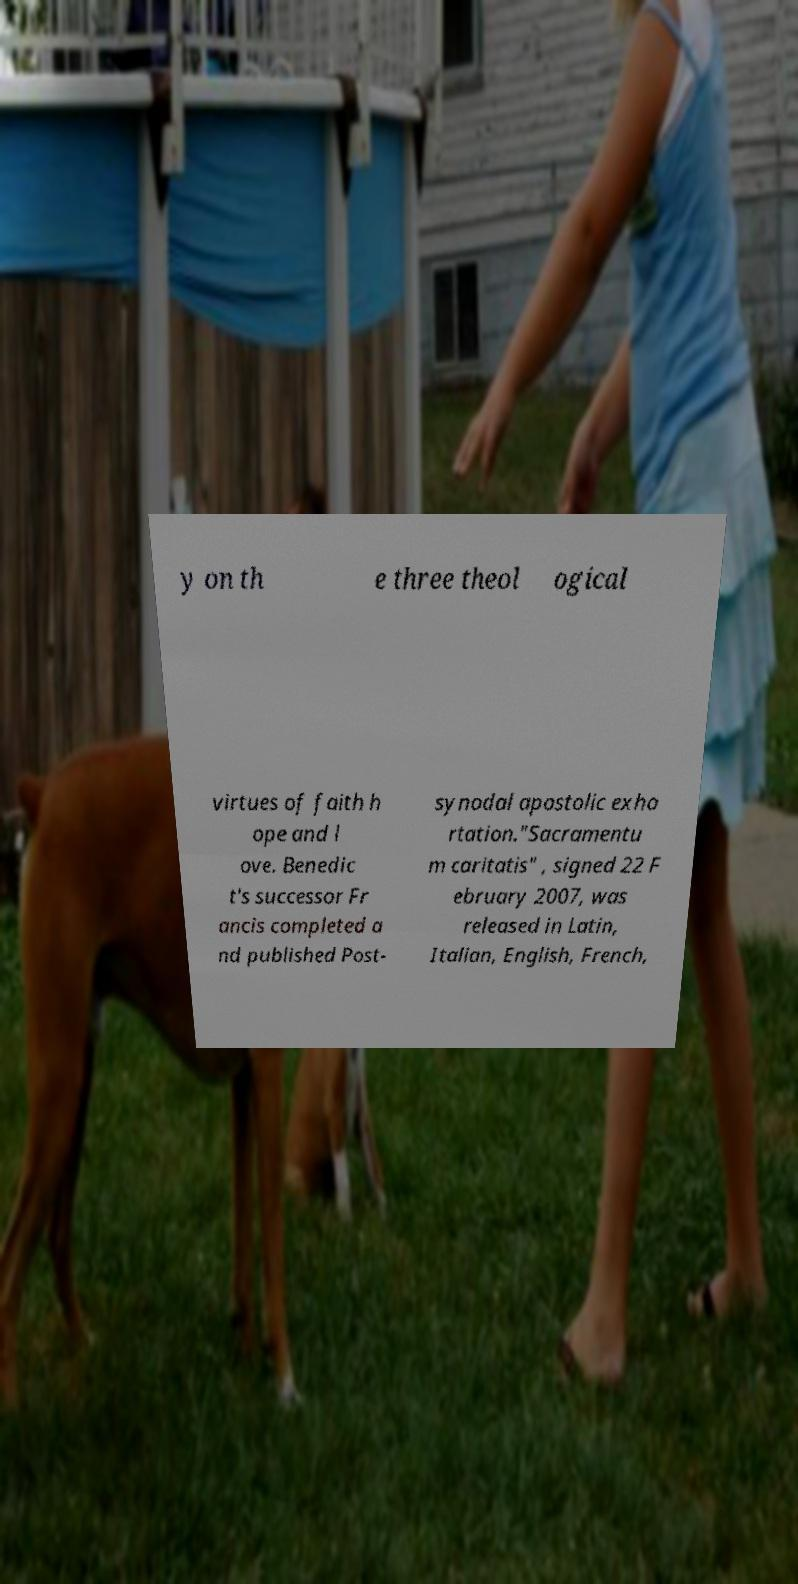I need the written content from this picture converted into text. Can you do that? y on th e three theol ogical virtues of faith h ope and l ove. Benedic t's successor Fr ancis completed a nd published Post- synodal apostolic exho rtation."Sacramentu m caritatis" , signed 22 F ebruary 2007, was released in Latin, Italian, English, French, 